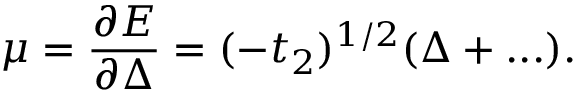<formula> <loc_0><loc_0><loc_500><loc_500>\mu = \frac { \partial E } { \partial \Delta } = ( - t _ { 2 } ) ^ { 1 / 2 } ( \Delta + \dots ) .</formula> 